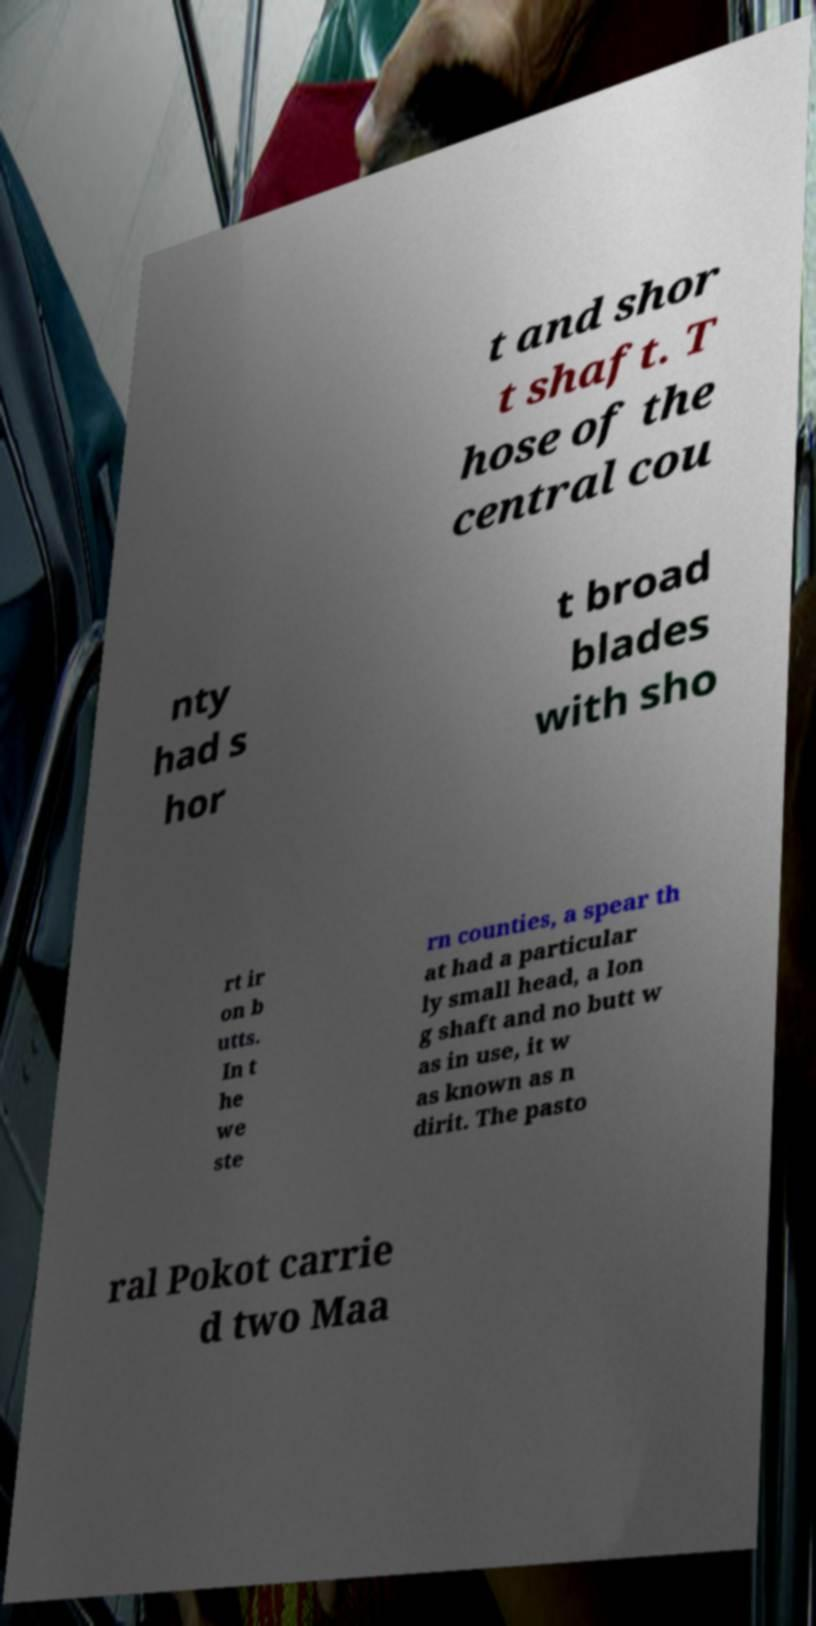Can you accurately transcribe the text from the provided image for me? t and shor t shaft. T hose of the central cou nty had s hor t broad blades with sho rt ir on b utts. In t he we ste rn counties, a spear th at had a particular ly small head, a lon g shaft and no butt w as in use, it w as known as n dirit. The pasto ral Pokot carrie d two Maa 